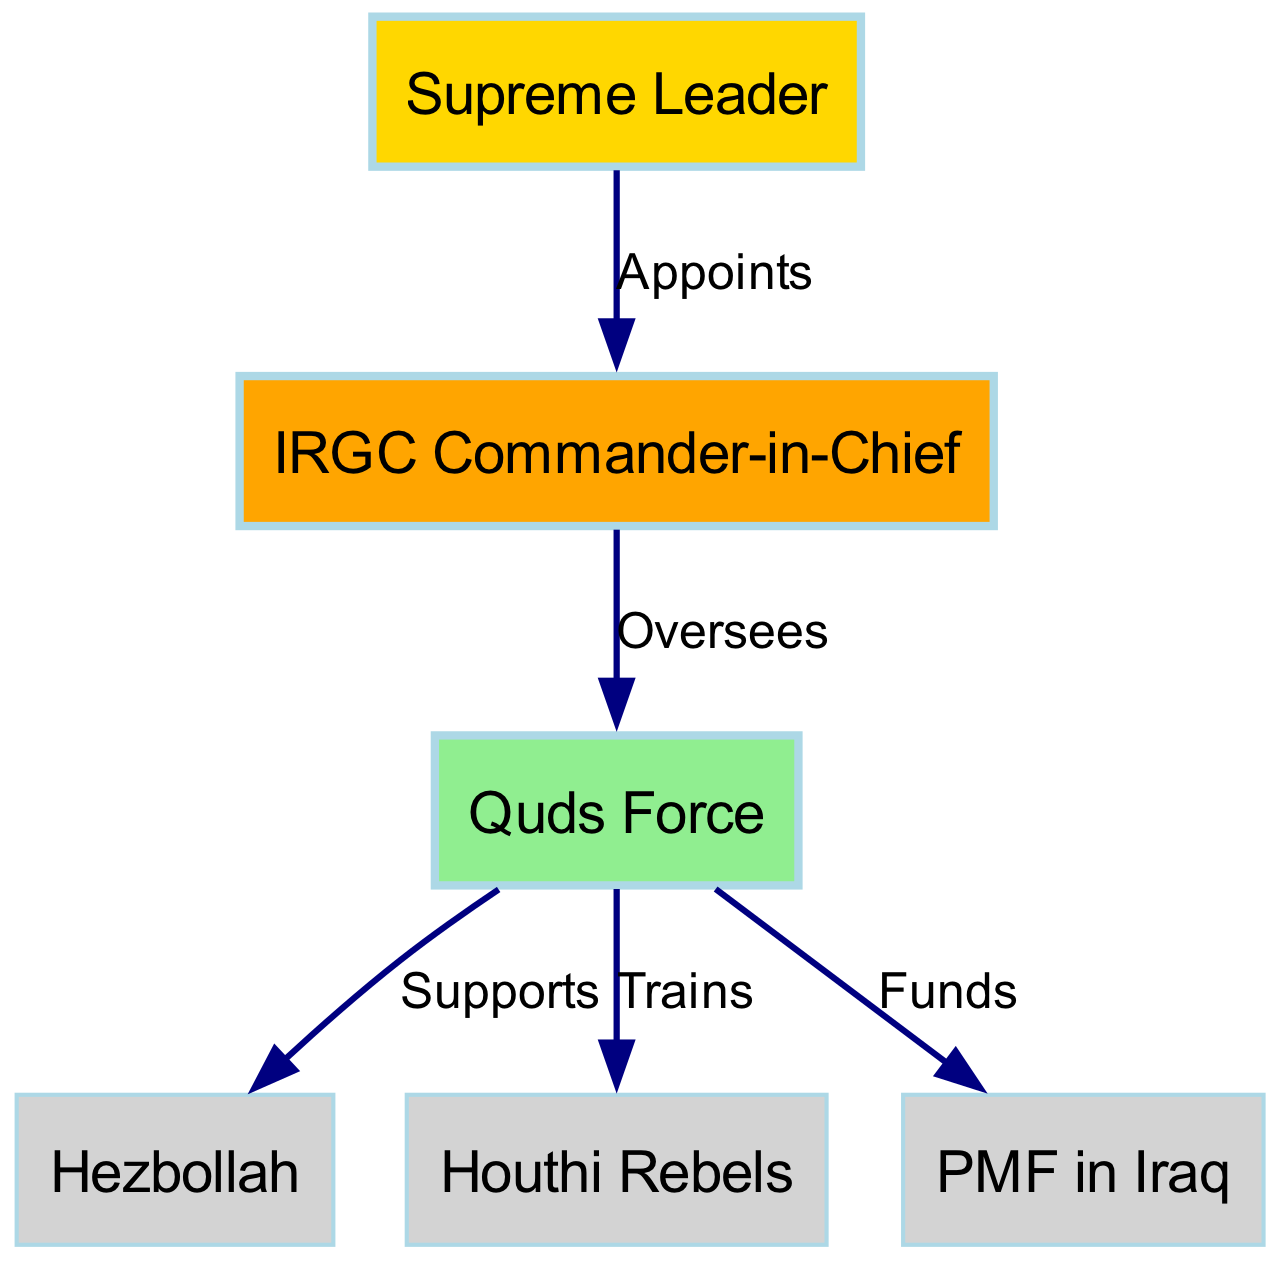What is the highest position in the hierarchy? The diagram shows the "Supreme Leader" at the top of the hierarchy, indicating that this is the highest position in the structure.
Answer: Supreme Leader Who oversees the Quds Force? The edge labeled "Oversees" between the "IRGC Commander-in-Chief" and the "Quds Force" indicates that the Commander-in-Chief is the entity that oversees the Quds Force.
Answer: IRGC Commander-in-Chief What relationship does the Quds Force have with Hezbollah? The diagram specifies that the Quds Force "Supports" Hezbollah, as shown by the edge labeled "Supports" connecting these two nodes.
Answer: Supports How many nodes are present in the diagram? The total number of unique entities represented in the diagram is 6, as listed under the nodes section.
Answer: 6 Which entities receive training from the Quds Force? The diagram shows a direct connection from the Quds Force to the "Houthi Rebels" with the label "Trains," indicating they are trained by the Quds Force.
Answer: Houthi Rebels How many edges are there in the diagram? By counting the connections drawn between the nodes in the diagram, we find there are 5 edges, each representing a relationship.
Answer: 5 What type of support does the Quds Force provide to Hezbollah? The label "Supports" on the edge connecting the Quds Force to Hezbollah clearly states the type of relationship they share.
Answer: Supports Which faction is financially supported by the Quds Force? The edge labeled "Funds" connects the Quds Force to the "PMF in Iraq," indicating that the PMF is financially supported.
Answer: PMF in Iraq Which entity is appointed by the Supreme Leader? The direct edge labeled "Appoints" shows that the "IRGC Commander-in-Chief" is the one appointed by the Supreme Leader.
Answer: IRGC Commander-in-Chief 